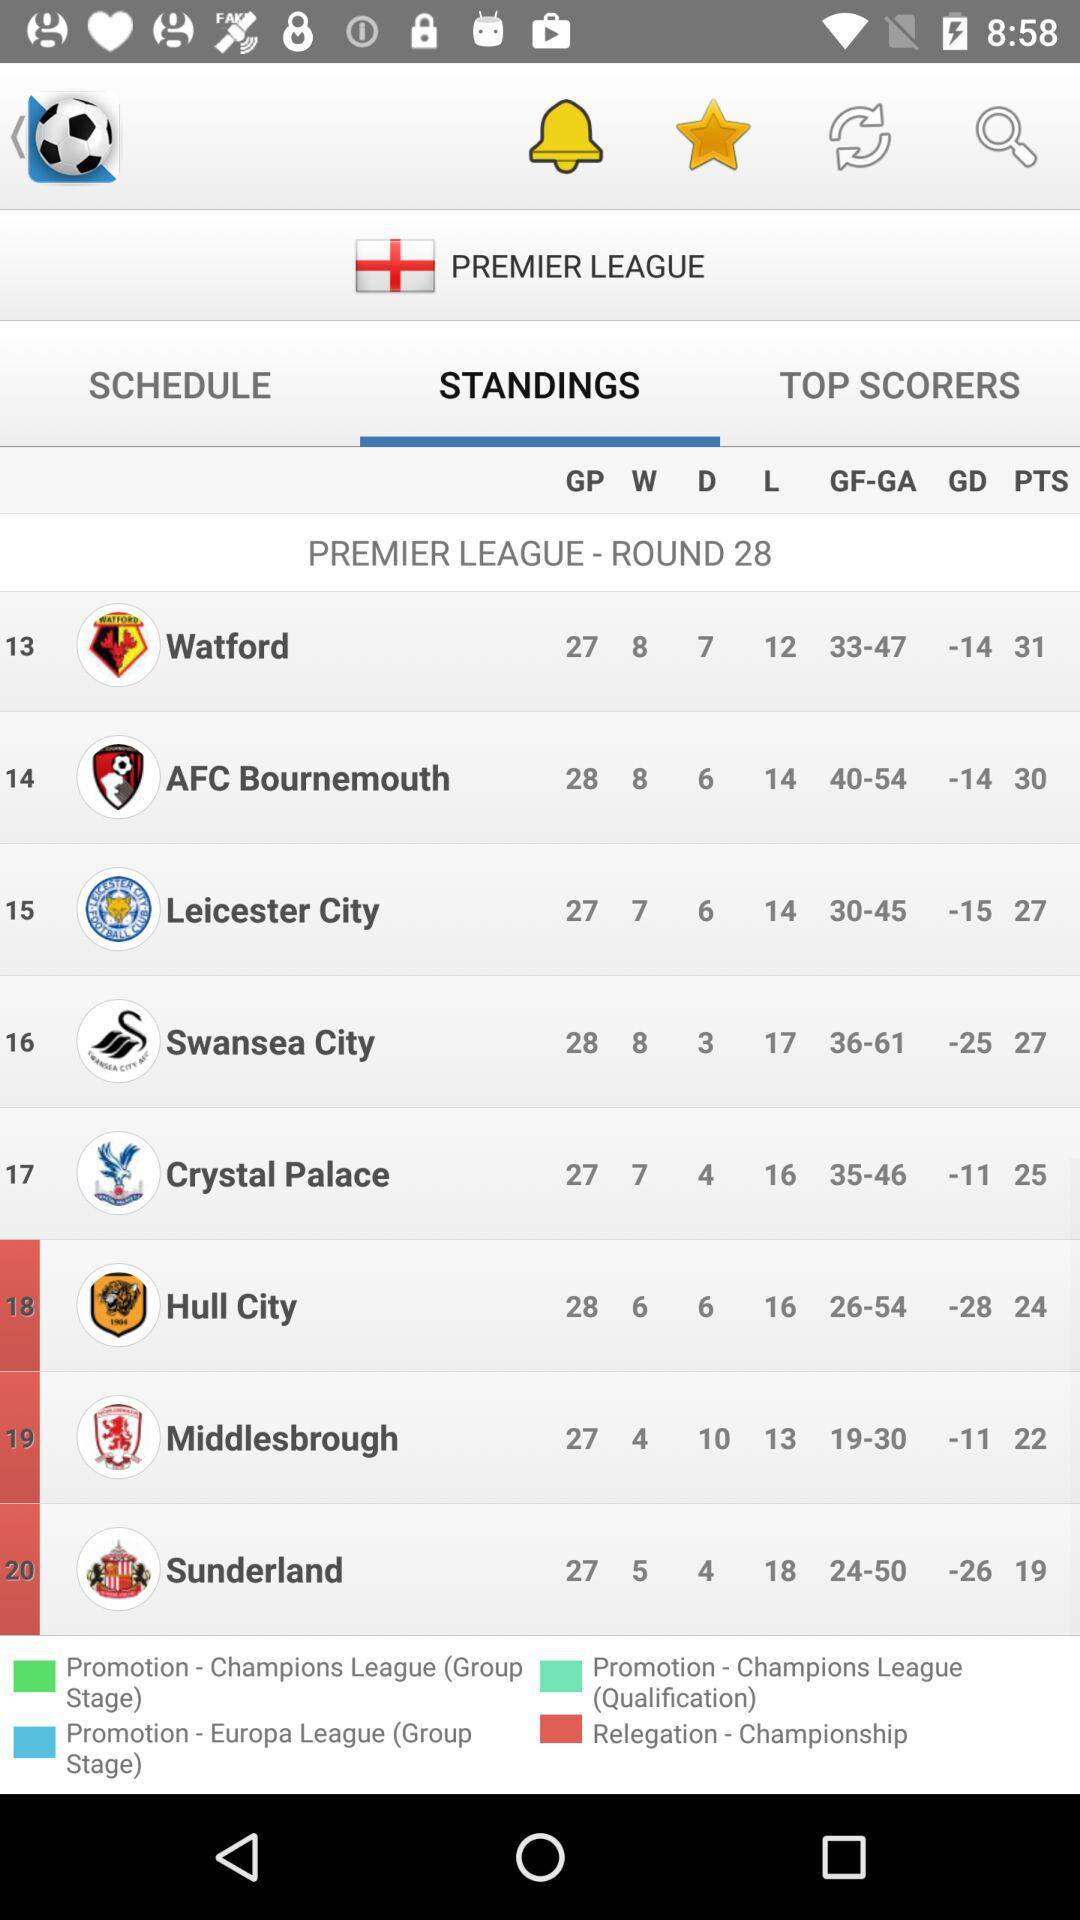Which team has a better goal difference, Sunderland or Middlesbrough?
Answer the question using a single word or phrase. Middlesbrough 